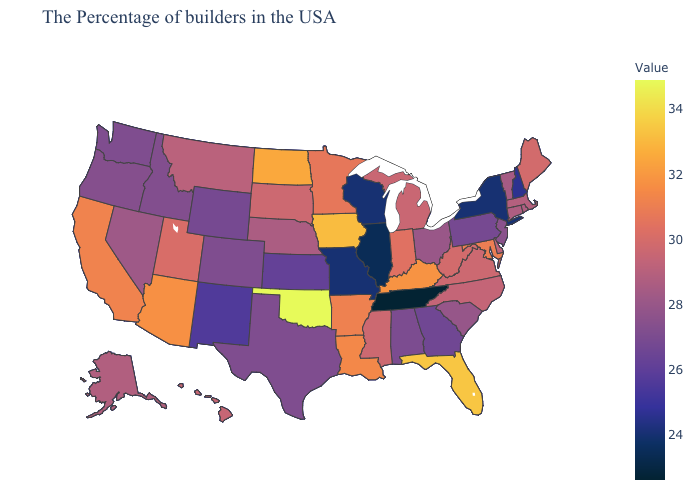Among the states that border Vermont , does New York have the lowest value?
Answer briefly. Yes. Which states have the lowest value in the USA?
Be succinct. Tennessee. Among the states that border Oklahoma , which have the highest value?
Keep it brief. Arkansas. Among the states that border Utah , which have the lowest value?
Quick response, please. New Mexico. Does Oklahoma have the highest value in the USA?
Write a very short answer. Yes. 